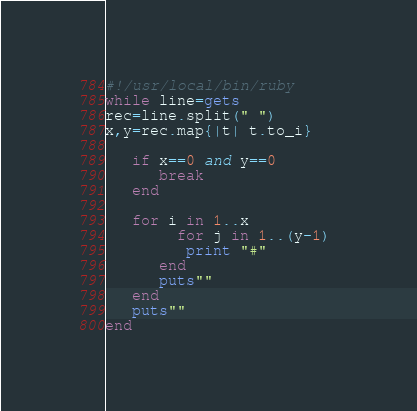Convert code to text. <code><loc_0><loc_0><loc_500><loc_500><_Ruby_>#!/usr/local/bin/ruby
while line=gets
rec=line.split(" ")
x,y=rec.map{|t| t.to_i}   

   if x==0 and y==0
      break
   end
   
   for i in 1..x
        for j in 1..(y-1)
         print "#"
      end
      puts""
   end
   puts""
end</code> 